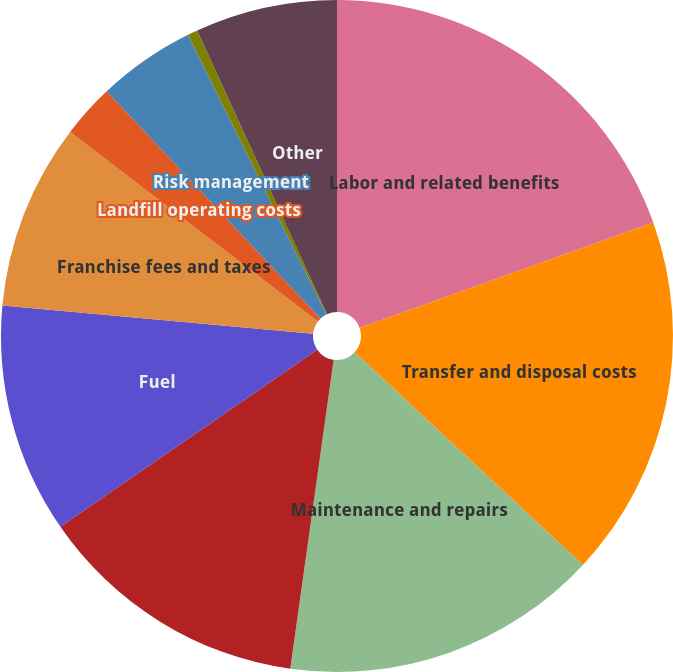Convert chart to OTSL. <chart><loc_0><loc_0><loc_500><loc_500><pie_chart><fcel>Labor and related benefits<fcel>Transfer and disposal costs<fcel>Maintenance and repairs<fcel>Transportation and subcontract<fcel>Fuel<fcel>Franchise fees and taxes<fcel>Landfill operating costs<fcel>Risk management<fcel>Cost of goods sold<fcel>Other<nl><fcel>19.52%<fcel>17.41%<fcel>15.29%<fcel>13.17%<fcel>11.06%<fcel>8.94%<fcel>2.59%<fcel>4.71%<fcel>0.48%<fcel>6.83%<nl></chart> 